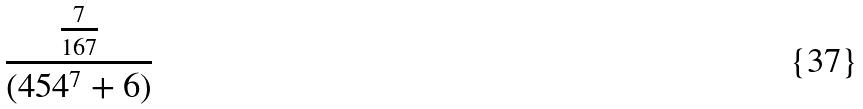Convert formula to latex. <formula><loc_0><loc_0><loc_500><loc_500>\frac { \frac { 7 } { 1 6 7 } } { ( 4 5 4 ^ { 7 } + 6 ) }</formula> 